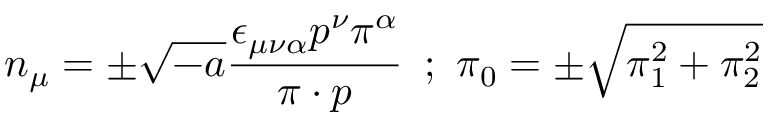<formula> <loc_0><loc_0><loc_500><loc_500>n _ { \mu } = \pm \sqrt { - a } \frac { \epsilon _ { \mu \nu \alpha } p ^ { \nu } \pi ^ { \alpha } } { \pi \cdot p } \, ; \, \pi _ { 0 } = \pm \sqrt { \pi _ { 1 } ^ { 2 } + \pi _ { 2 } ^ { 2 } }</formula> 